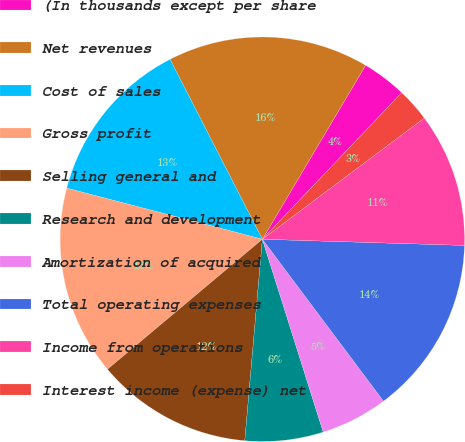<chart> <loc_0><loc_0><loc_500><loc_500><pie_chart><fcel>(In thousands except per share<fcel>Net revenues<fcel>Cost of sales<fcel>Gross profit<fcel>Selling general and<fcel>Research and development<fcel>Amortization of acquired<fcel>Total operating expenses<fcel>Income from operations<fcel>Interest income (expense) net<nl><fcel>3.57%<fcel>16.07%<fcel>13.39%<fcel>15.18%<fcel>12.5%<fcel>6.25%<fcel>5.36%<fcel>14.29%<fcel>10.71%<fcel>2.68%<nl></chart> 